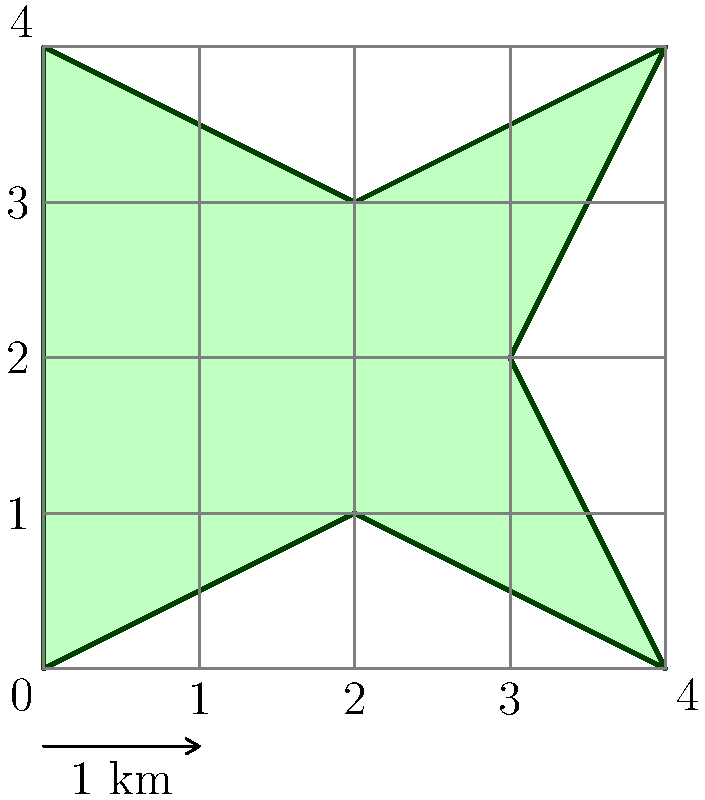Using satellite imagery, an irregularly shaped farmland has been mapped onto a grid where each square represents 1 square kilometer. Estimate the area of the farmland using the count-squares method. How many square kilometers does the farmland approximately cover? To estimate the area of the irregularly shaped farmland using the count-squares method, we'll follow these steps:

1. Count the number of full squares within the farmland boundary:
   There are 6 full squares completely inside the farmland.

2. Count the number of partial squares that the farmland boundary intersects:
   There are 10 partial squares along the boundary.

3. Estimate the area of partial squares:
   As a general rule, we can assume that on average, half of each partial square is inside the farmland. So we'll count each partial square as 0.5.

4. Calculate the total area:
   - Full squares: 6 × 1 km² = 6 km²
   - Partial squares: 10 × 0.5 × 1 km² = 5 km²
   - Total area = Full squares + Partial squares
   - Total area = 6 km² + 5 km² = 11 km²

Therefore, the estimated area of the farmland is approximately 11 square kilometers.

This method provides a reasonable estimate for irregular shapes when precise measurements are not available or practical. In agricultural economics and climate change impact studies, such estimates can be useful for assessing land use, crop yields, and potential effects of climate change on agricultural areas.
Answer: 11 km² 